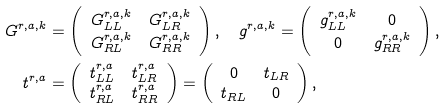Convert formula to latex. <formula><loc_0><loc_0><loc_500><loc_500>G ^ { r , a , k } & = \left ( \begin{array} { c c } G _ { L L } ^ { r , a , k } & G _ { L R } ^ { r , a , k } \\ G _ { R L } ^ { r , a , k } & G _ { R R } ^ { r , a , k } \end{array} \right ) , \quad g ^ { r , a , k } = \left ( \begin{array} { c c } g _ { L L } ^ { r , a , k } & 0 \\ 0 & g _ { R R } ^ { r , a , k } \end{array} \right ) , \quad \\ t ^ { r , a } & = \left ( \begin{array} { c c } t _ { L L } ^ { r , a } & t _ { L R } ^ { r , a } \\ t _ { R L } ^ { r , a } & t _ { R R } ^ { r , a } \end{array} \right ) = \left ( \begin{array} { c c } 0 & t _ { L R } \\ t _ { R L } & 0 \end{array} \right ) ,</formula> 